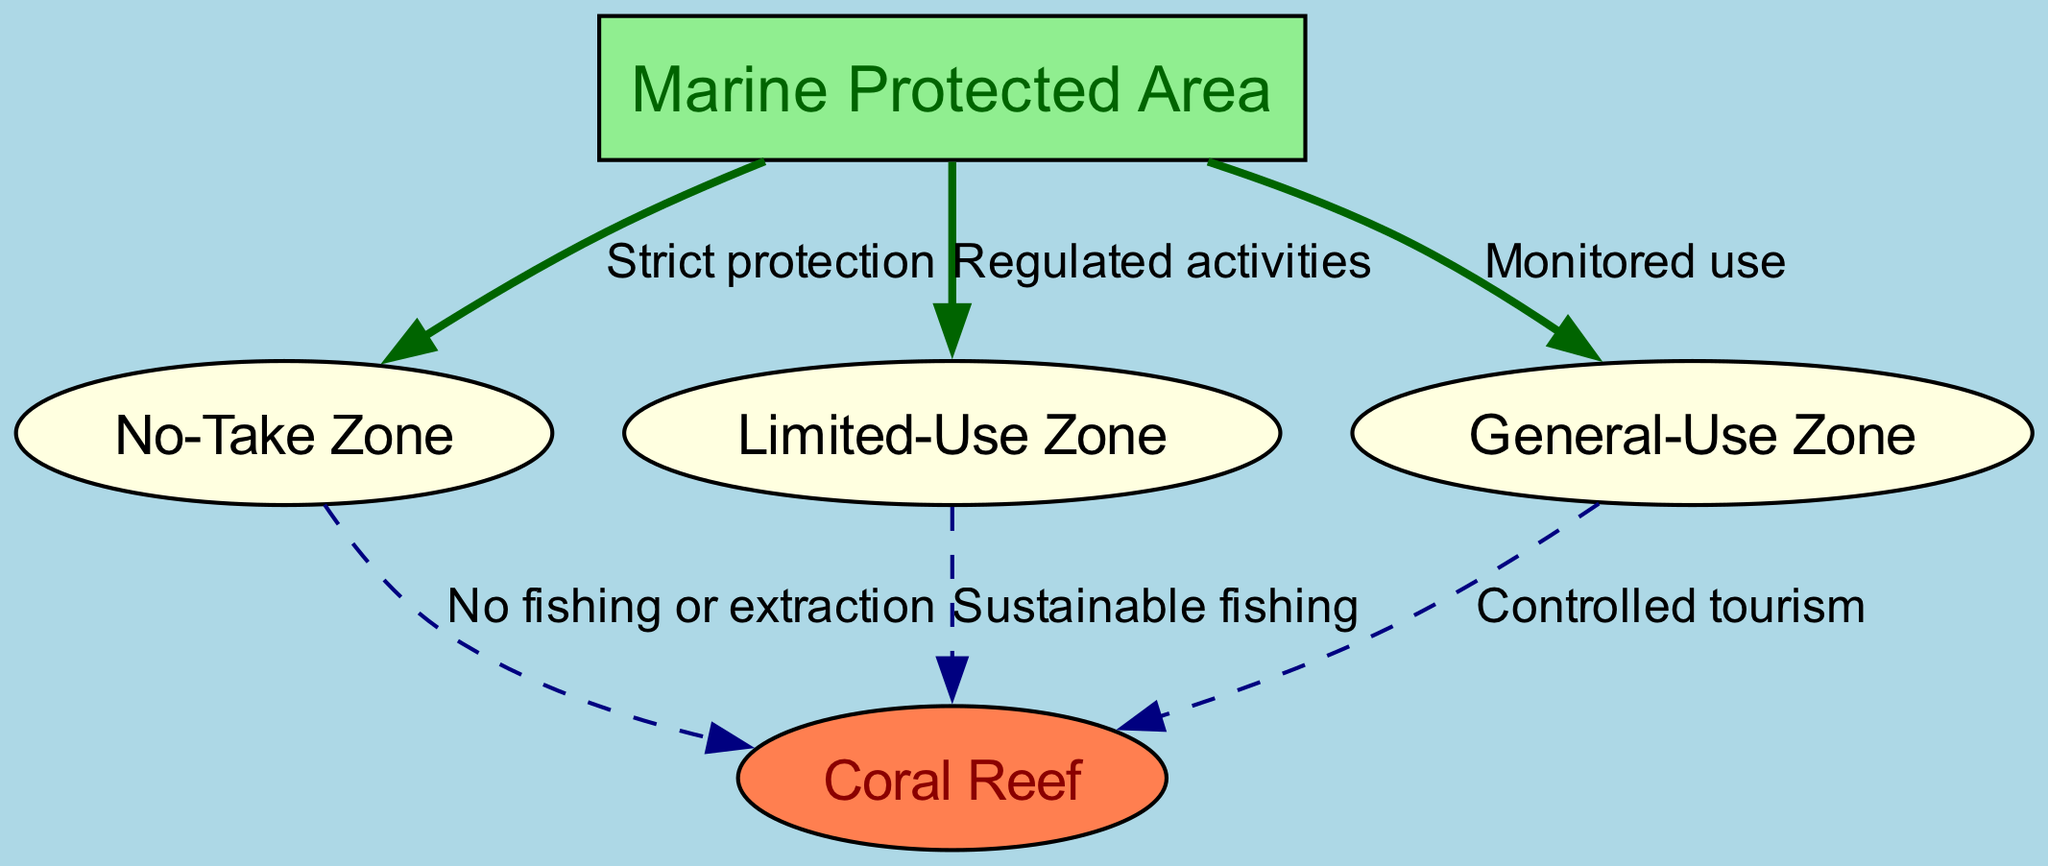What is the main area depicted in the diagram? The diagram identifies "Marine Protected Area" as the central focus, distinguished by a unique label and node style.
Answer: Marine Protected Area How many total nodes are present in the diagram? By counting, there are five nodes labeled "Marine Protected Area," "No-Take Zone," "Limited-Use Zone," "General-Use Zone," and "Coral Reef."
Answer: 5 What type of zone is labeled as "No-Take Zone"? The "No-Take Zone" is categorized under "Marine Protected Area" which indicates strict protection.
Answer: Strict protection What is permitted in the "Limited-Use Zone"? The "Limited-Use Zone" allows for regulated activities, indicating some level of use under certain regulations.
Answer: Regulated activities How many edges connect to the "Coral Reef"? The "Coral Reef" connects to three different zones via edges explaining the activities allowed in each zone (No fishing or extraction, Sustainable fishing, Controlled tourism).
Answer: 3 What is the relationship between the "General-Use Zone" and "Coral Reef"? The relationship indicates that the General-Use Zone allows for controlled tourism, showing some usage of the coral reef in this area.
Answer: Controlled tourism Which zone has the restriction of “No fishing or extraction”? The "No-Take Zone" is directly linked to "Coral Reef," indicating that there are no fishing or extraction activities allowed in this zone.
Answer: No-Take Zone What kind of activities occur in the "General-Use Zone"? Activities are monitored, indicating oversight of the allowed uses to protect the marine environment.
Answer: Monitored use What connects the "Marine Protected Area" to the "No-Take Zone"? The edge labeled "Strict protection" connects these two areas, indicating a strong regulation against exploitation.
Answer: Strict protection Which zone facilitates “Sustainable fishing”? The "Limited-Use Zone" is designated to permit sustainable fishing, balancing environmental protection with fishing activity.
Answer: Limited-Use Zone 